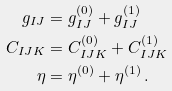Convert formula to latex. <formula><loc_0><loc_0><loc_500><loc_500>g _ { I J } & = g _ { I J } ^ { ( 0 ) } + g _ { I J } ^ { ( 1 ) } \\ C _ { I J K } & = C _ { I J K } ^ { ( 0 ) } + C _ { I J K } ^ { ( 1 ) } \\ \eta & = \eta ^ { ( 0 ) } + \eta ^ { ( 1 ) } \, .</formula> 